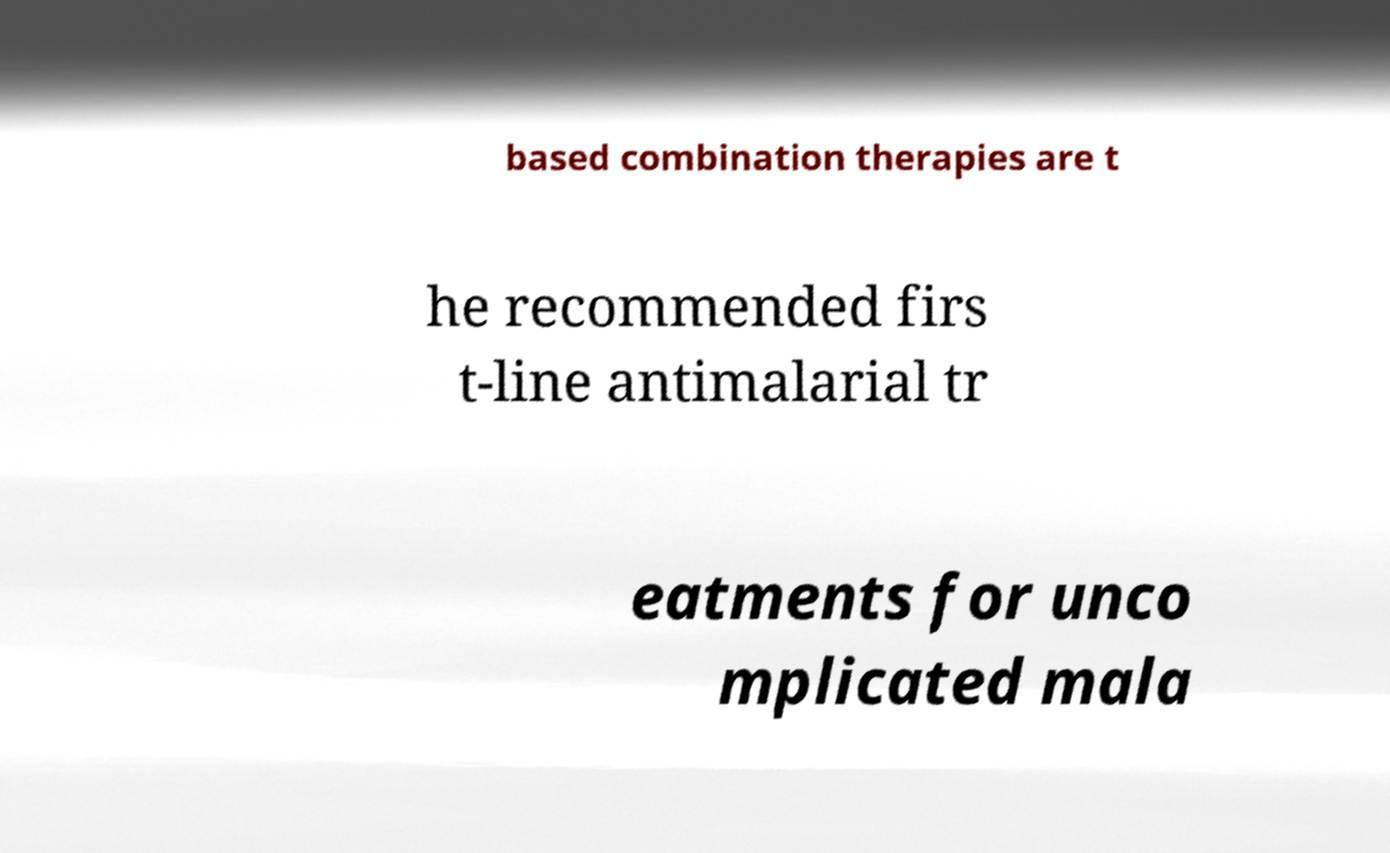There's text embedded in this image that I need extracted. Can you transcribe it verbatim? based combination therapies are t he recommended firs t-line antimalarial tr eatments for unco mplicated mala 